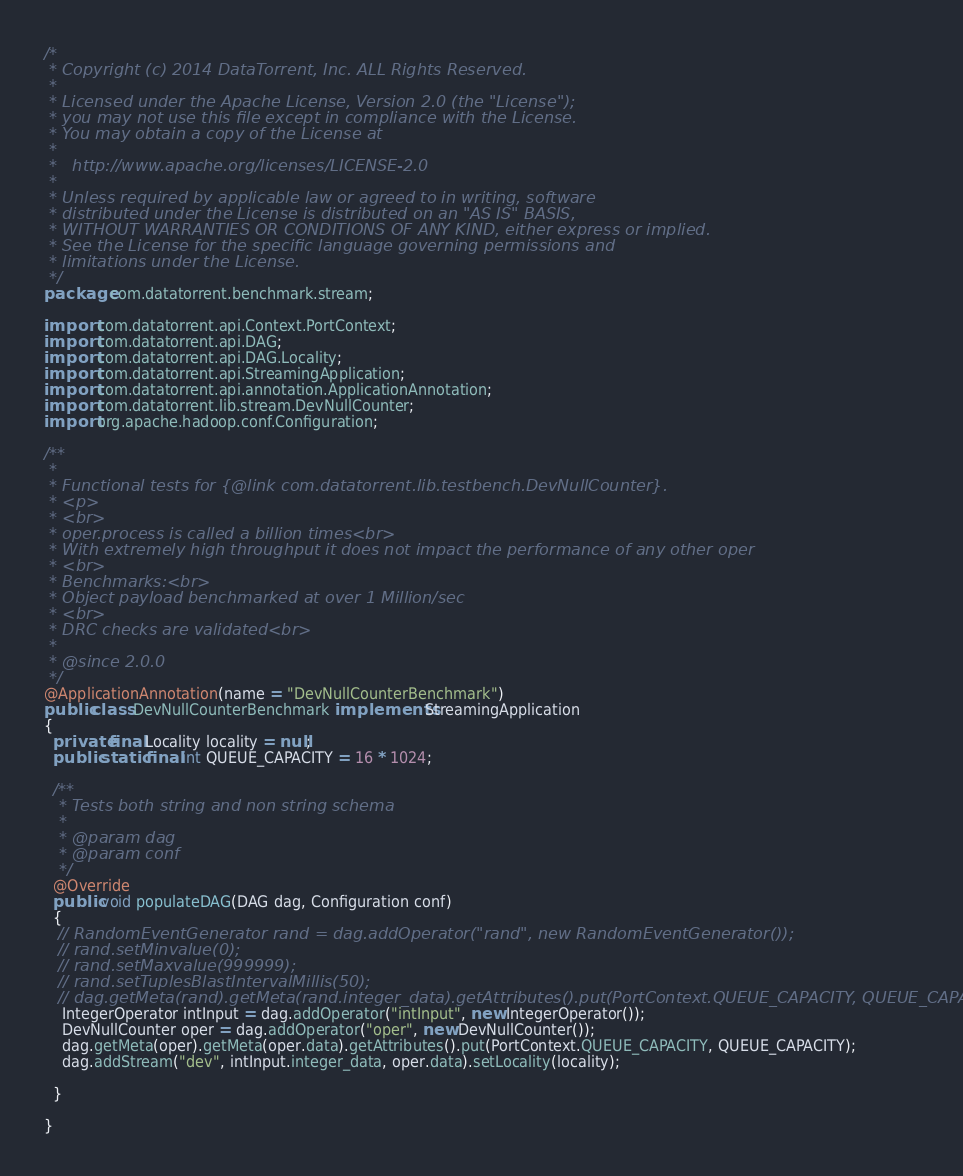Convert code to text. <code><loc_0><loc_0><loc_500><loc_500><_Java_>/*
 * Copyright (c) 2014 DataTorrent, Inc. ALL Rights Reserved.
 *
 * Licensed under the Apache License, Version 2.0 (the "License");
 * you may not use this file except in compliance with the License.
 * You may obtain a copy of the License at
 *
 *   http://www.apache.org/licenses/LICENSE-2.0
 *
 * Unless required by applicable law or agreed to in writing, software
 * distributed under the License is distributed on an "AS IS" BASIS,
 * WITHOUT WARRANTIES OR CONDITIONS OF ANY KIND, either express or implied.
 * See the License for the specific language governing permissions and
 * limitations under the License.
 */
package com.datatorrent.benchmark.stream;

import com.datatorrent.api.Context.PortContext;
import com.datatorrent.api.DAG;
import com.datatorrent.api.DAG.Locality;
import com.datatorrent.api.StreamingApplication;
import com.datatorrent.api.annotation.ApplicationAnnotation;
import com.datatorrent.lib.stream.DevNullCounter;
import org.apache.hadoop.conf.Configuration;

/**
 *
 * Functional tests for {@link com.datatorrent.lib.testbench.DevNullCounter}.
 * <p>
 * <br>
 * oper.process is called a billion times<br>
 * With extremely high throughput it does not impact the performance of any other oper
 * <br>
 * Benchmarks:<br>
 * Object payload benchmarked at over 1 Million/sec
 * <br>
 * DRC checks are validated<br>
 *
 * @since 2.0.0
 */
@ApplicationAnnotation(name = "DevNullCounterBenchmark")
public class DevNullCounterBenchmark implements StreamingApplication
{
  private final Locality locality = null;
  public static final int QUEUE_CAPACITY = 16 * 1024;

  /**
   * Tests both string and non string schema
   *
   * @param dag
   * @param conf
   */
  @Override
  public void populateDAG(DAG dag, Configuration conf)
  {
   // RandomEventGenerator rand = dag.addOperator("rand", new RandomEventGenerator());
   // rand.setMinvalue(0);
   // rand.setMaxvalue(999999);
   // rand.setTuplesBlastIntervalMillis(50);
   // dag.getMeta(rand).getMeta(rand.integer_data).getAttributes().put(PortContext.QUEUE_CAPACITY, QUEUE_CAPACITY);
    IntegerOperator intInput = dag.addOperator("intInput", new IntegerOperator());
    DevNullCounter oper = dag.addOperator("oper", new DevNullCounter());
    dag.getMeta(oper).getMeta(oper.data).getAttributes().put(PortContext.QUEUE_CAPACITY, QUEUE_CAPACITY);
    dag.addStream("dev", intInput.integer_data, oper.data).setLocality(locality);

  }

}
</code> 